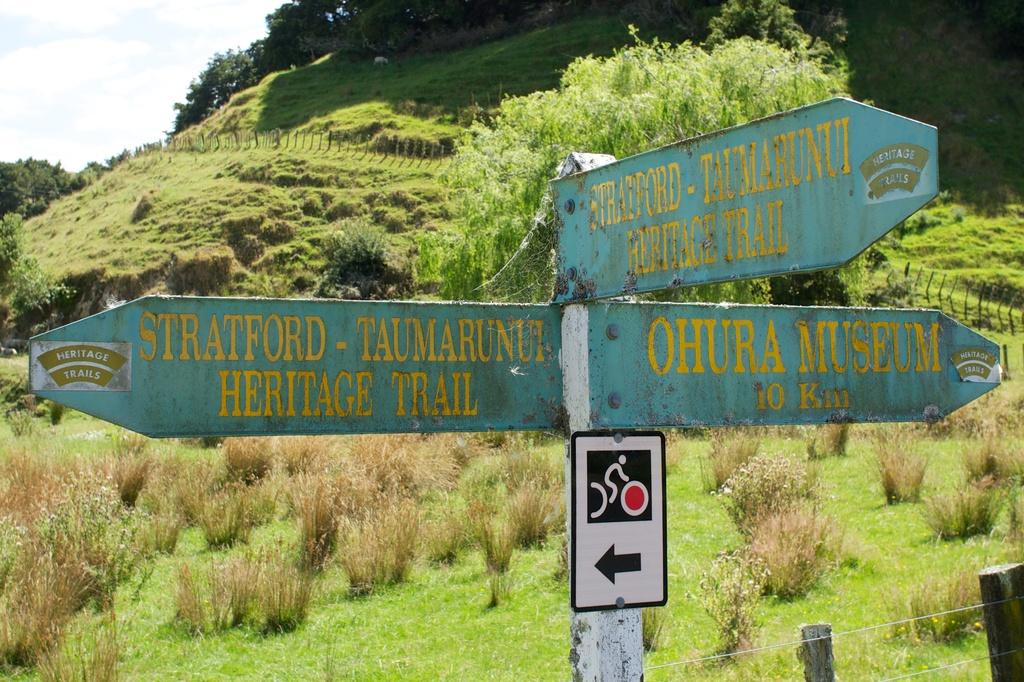How far is it to the ohura museum?
Offer a terse response. 10 km. What trail is to the left?
Offer a terse response. Heritage trail. 